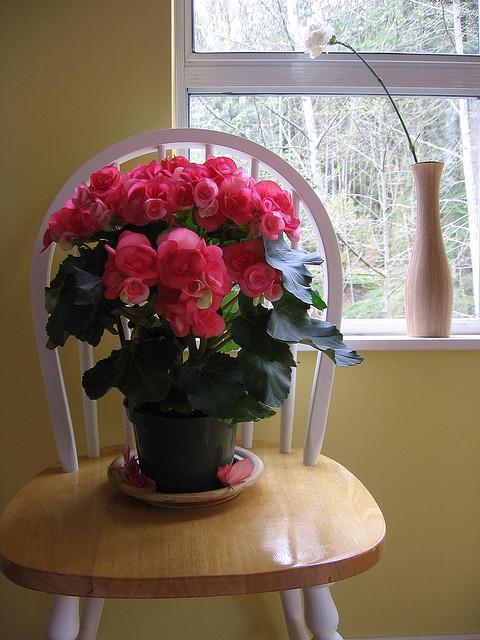How many vases are visible?
Give a very brief answer. 2. How many feet does the man have on the skateboard?
Give a very brief answer. 0. 